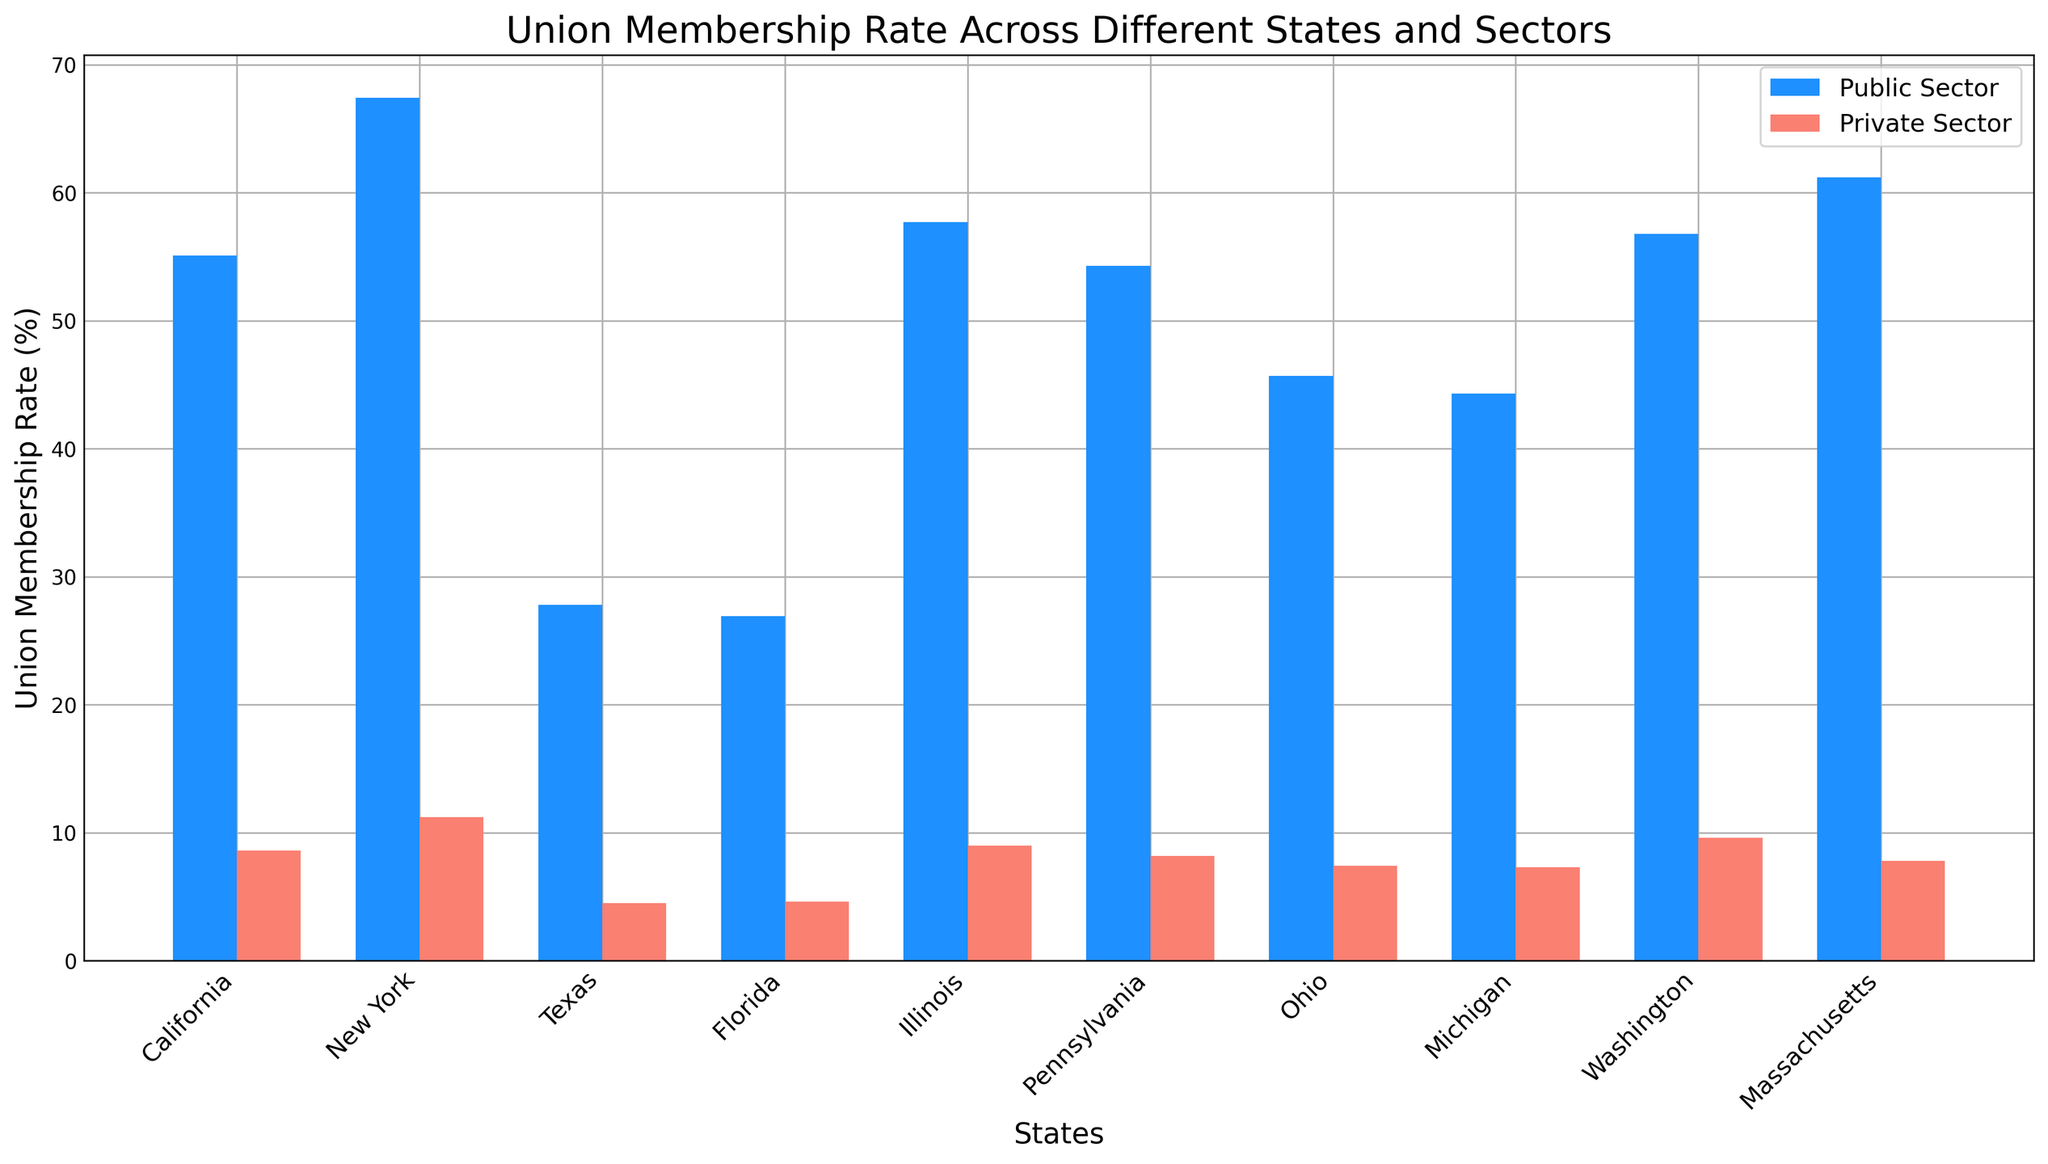Which state has the highest union membership rate in the public sector? To find this, we look for the tallest blue bar in the plot representing the public sector rates. The tallest blue bar corresponds to New York.
Answer: New York Which state has the lowest union membership rate in the private sector? We search for the shortest red bar in the plot representing private sector rates. The shortest red bar corresponds to Texas.
Answer: Texas What is the difference in union membership rates between the public and private sectors in California? First, find the heights of the blue and red bars for California, which are 55.1% and 8.6% respectively. Subtract the private sector rate from the public sector rate: 55.1 - 8.6 = 46.5.
Answer: 46.5 How does the union membership rate in the public sector of Massachusetts compare to Illinois? Compare the heights of the blue bars for Massachusetts and Illinois, which are 61.2% and 57.7% respectively. Massachusetts has a higher rate.
Answer: Massachusetts is higher What is the average union membership rate for the public sector across all states? Sum the public sector rates for all states and divide by the number of states: (55.1 + 67.4 + 27.8 + 26.9 + 57.7 + 54.3 + 45.7 + 44.3 + 56.8 + 61.2) / 10 = 49.12.
Answer: 49.12 In how many states is the union membership rate for the public sector above 50%? Count the number of blue bars exceeding the 50% mark: California, New York, Illinois, Pennsylvania, Washington, and Massachusetts. There are 6 states.
Answer: 6 Which sector has the broader range of union membership rates, public or private? Determine the range for each sector by subtracting the smallest value from the largest value. For the public sector, the range is 67.4 - 26.9 = 40.5. For the private sector, the range is 11.2 - 4.5 = 6.7. The public sector has a broader range.
Answer: Public sector Is the union membership rate in Washington’s private sector higher or lower than the rate in Pennsylvania’s private sector? Compare the heights of the red bars for Washington and Pennsylvania, which are 9.6% and 8.2% respectively. Washington's rate is higher.
Answer: Higher 